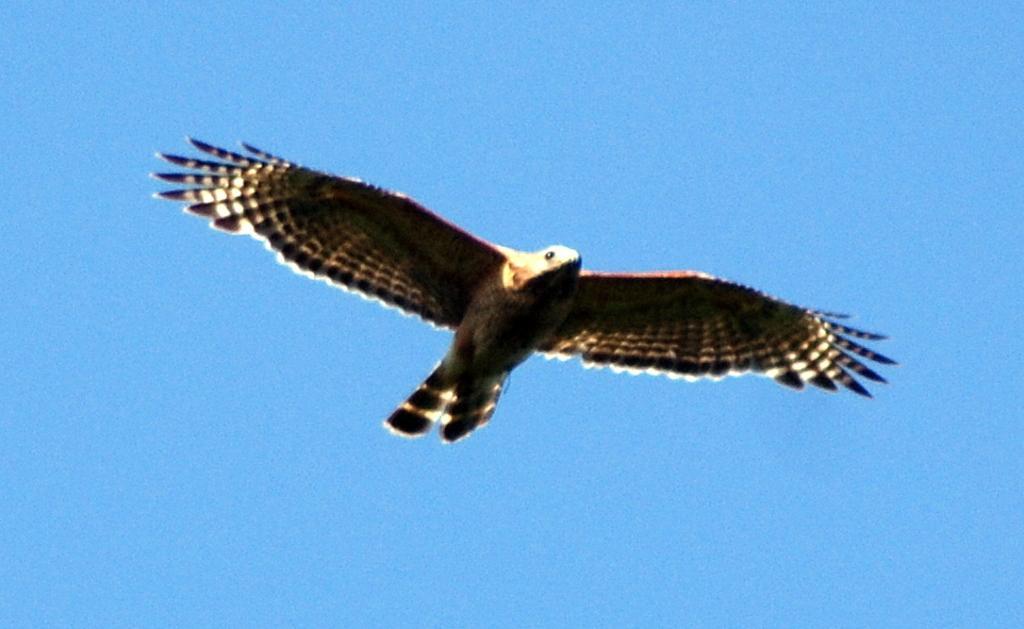Please provide a concise description of this image. In the picture we can see an eagle flying in the air, which is black in color with some white lines in the wings and in the background we can see a sky which is blue in color. 